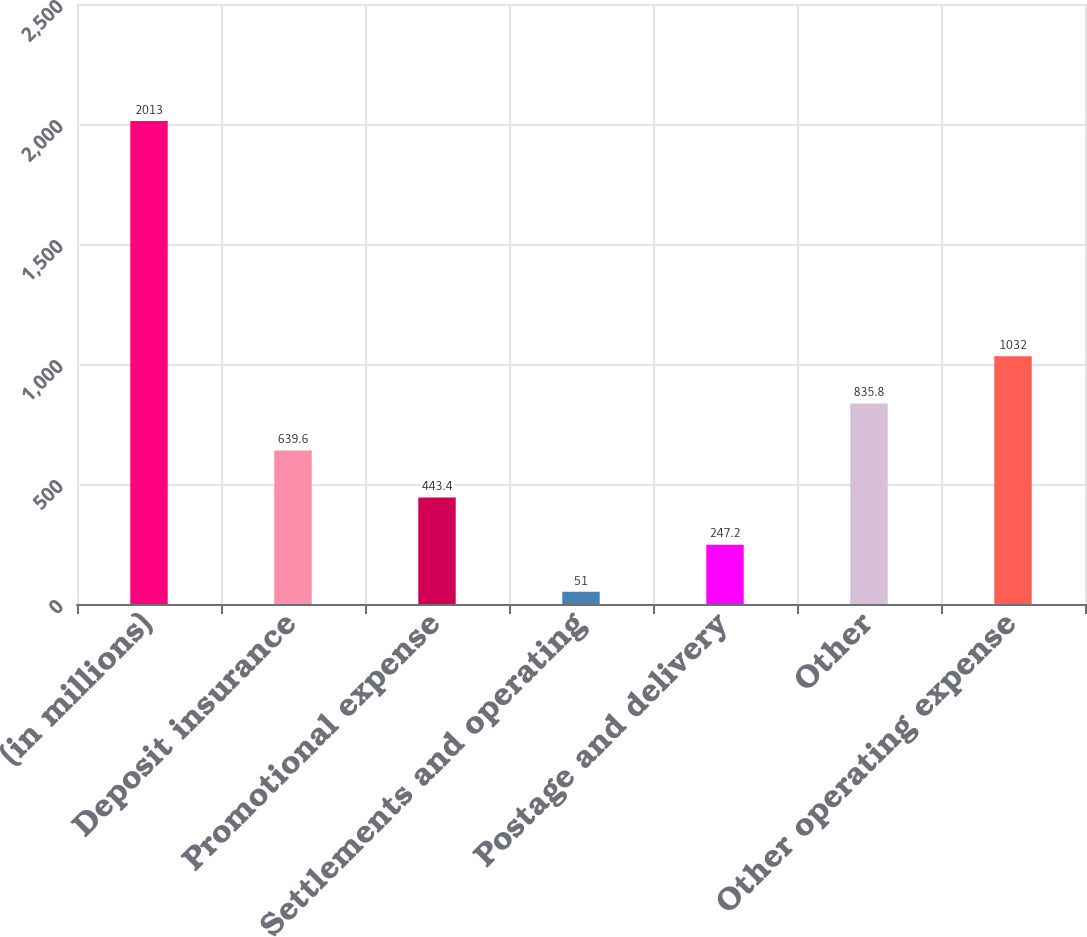<chart> <loc_0><loc_0><loc_500><loc_500><bar_chart><fcel>(in millions)<fcel>Deposit insurance<fcel>Promotional expense<fcel>Settlements and operating<fcel>Postage and delivery<fcel>Other<fcel>Other operating expense<nl><fcel>2013<fcel>639.6<fcel>443.4<fcel>51<fcel>247.2<fcel>835.8<fcel>1032<nl></chart> 